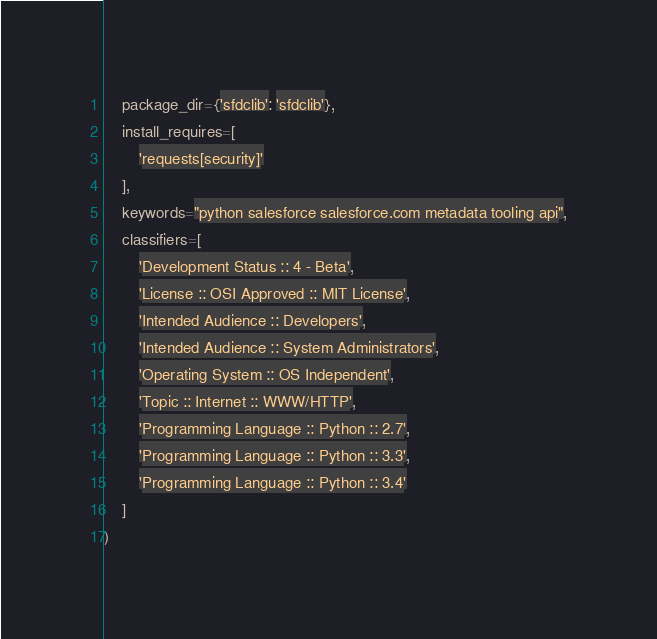<code> <loc_0><loc_0><loc_500><loc_500><_Python_>    package_dir={'sfdclib': 'sfdclib'},
    install_requires=[
        'requests[security]'
    ],
    keywords="python salesforce salesforce.com metadata tooling api",
    classifiers=[
        'Development Status :: 4 - Beta',
        'License :: OSI Approved :: MIT License',
        'Intended Audience :: Developers',
        'Intended Audience :: System Administrators',
        'Operating System :: OS Independent',
        'Topic :: Internet :: WWW/HTTP',
        'Programming Language :: Python :: 2.7',
        'Programming Language :: Python :: 3.3',
        'Programming Language :: Python :: 3.4'
    ]
)
</code> 